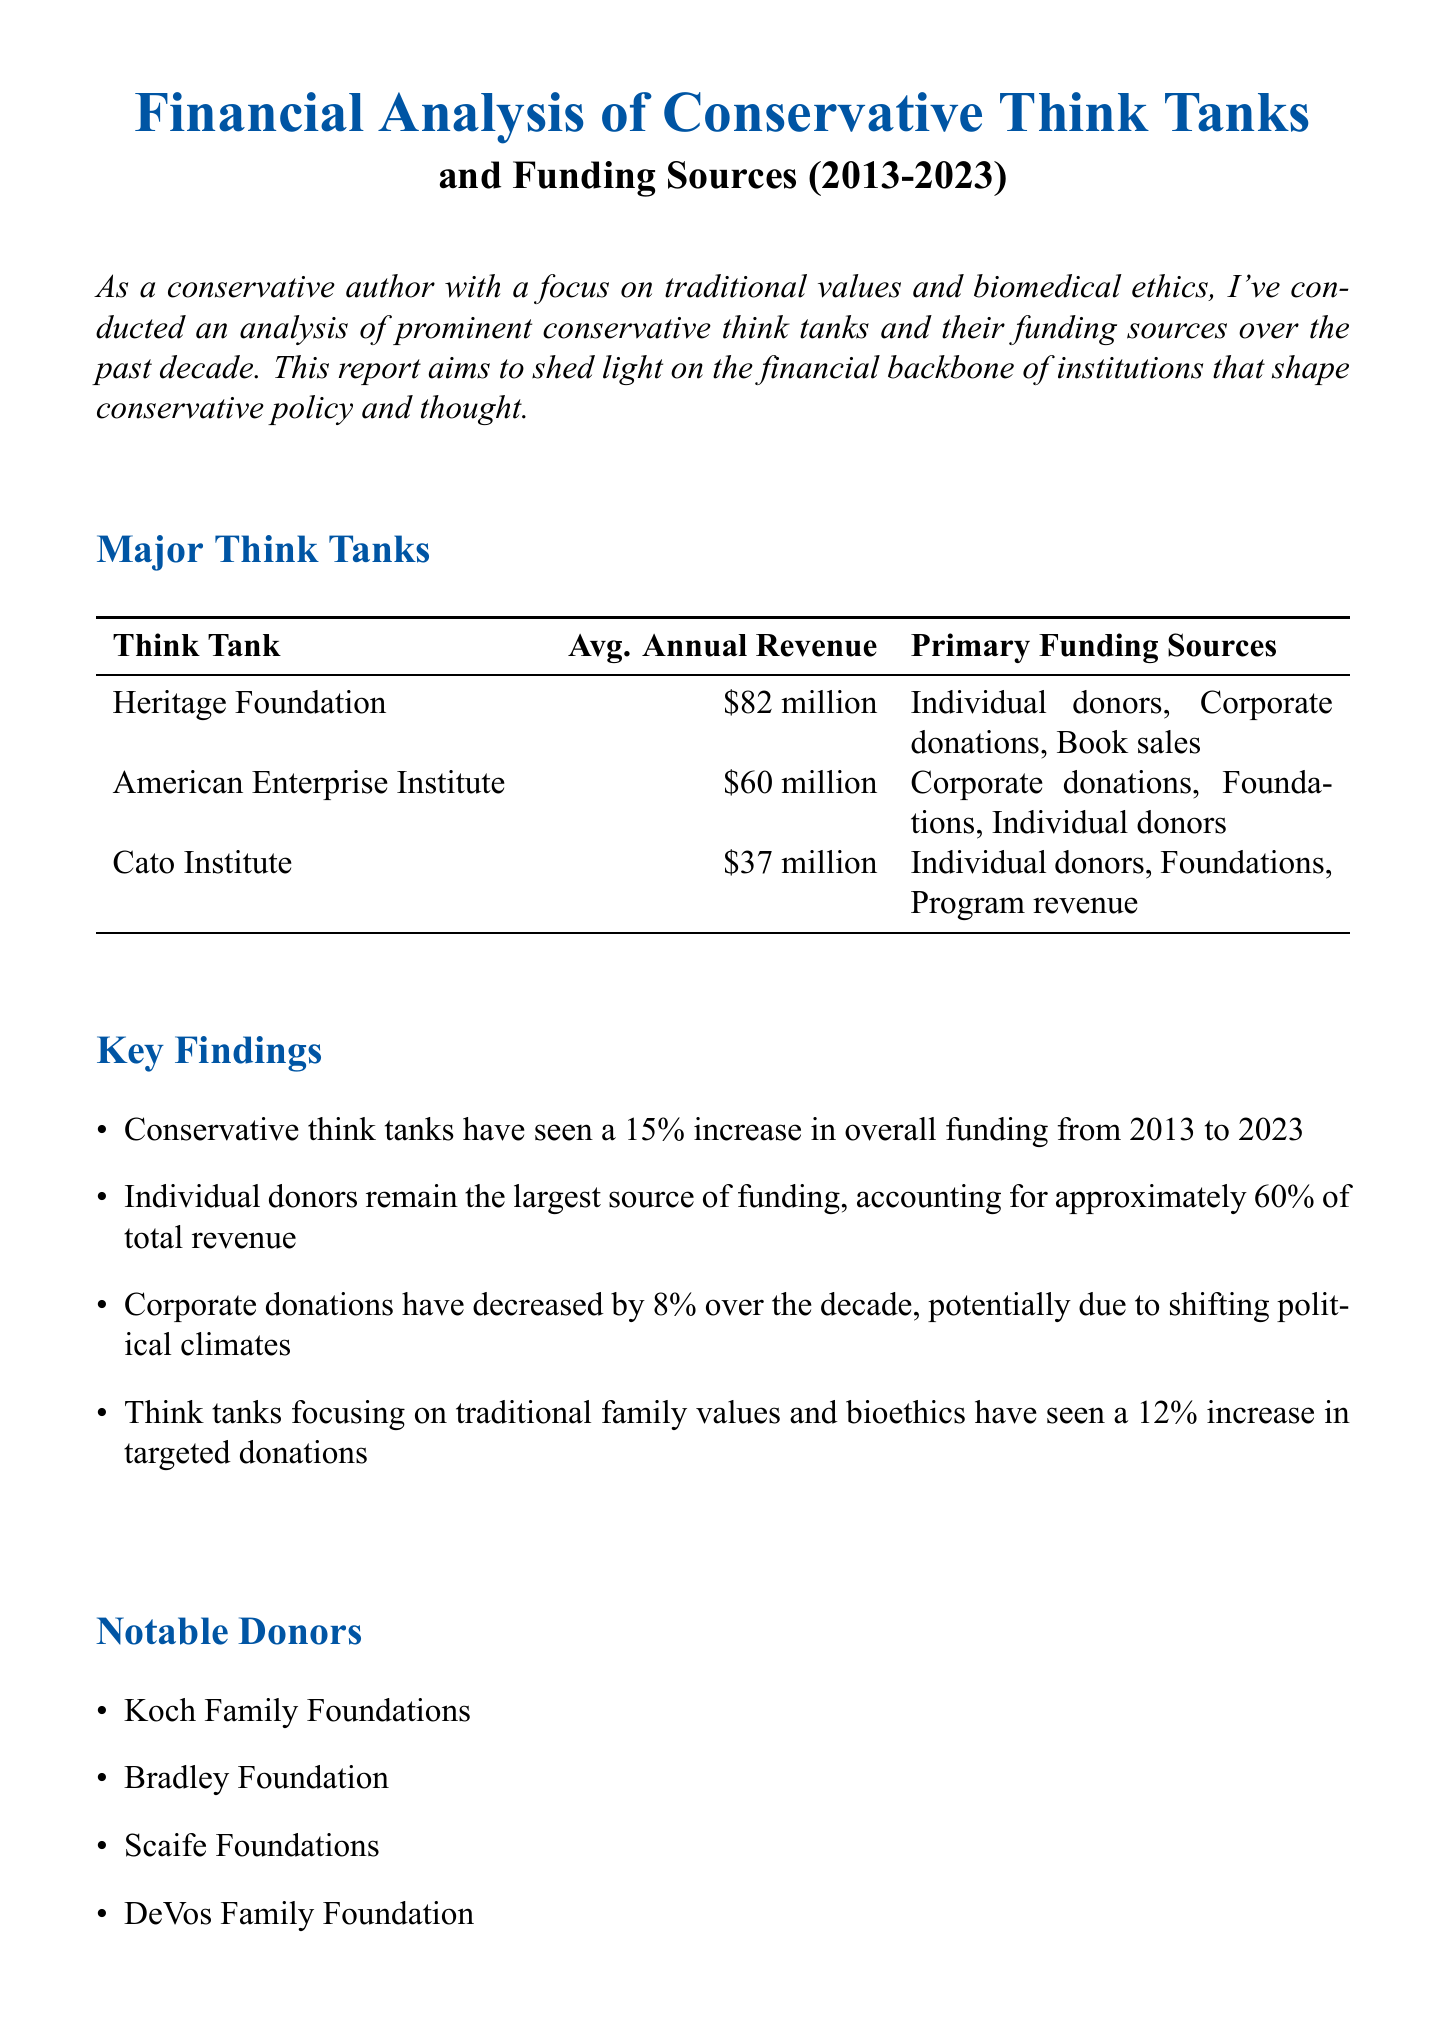what is the average annual revenue of the Heritage Foundation? The average annual revenue of the Heritage Foundation is stated directly in the document.
Answer: $82 million what percentage of total revenue comes from individual donors? The document specifically notes that individual donors account for approximately 60% of total revenue.
Answer: 60% which think tank has the lowest average annual revenue? The average annual revenues for the think tanks are compared in the document.
Answer: Cato Institute what was the overall funding increase for conservative think tanks from 2013 to 2023? The document mentions a specific percentage increase in overall funding over the specified time period.
Answer: 15% who is one of the notable donors mentioned in the report? The document lists several notable donors, any of which would be a correct answer.
Answer: Koch Family Foundations which type of donations has decreased over the decade? The document explicitly states that corporate donations have decreased, providing insight into funding sources.
Answer: Corporate donations what is the focus of think tanks that have seen an increase in targeted donations? The key findings in the document provide context about the specific focus of these think tanks.
Answer: Traditional family values and bioethics how many major think tanks are discussed in this report? The document lists a specific number of major think tanks analyzed during the decade.
Answer: 3 what is the title of this financial report? The title is provided at the beginning of the document and summarizes the report's focus.
Answer: Financial Analysis of Conservative Think Tanks and Funding Sources (2013-2023) 